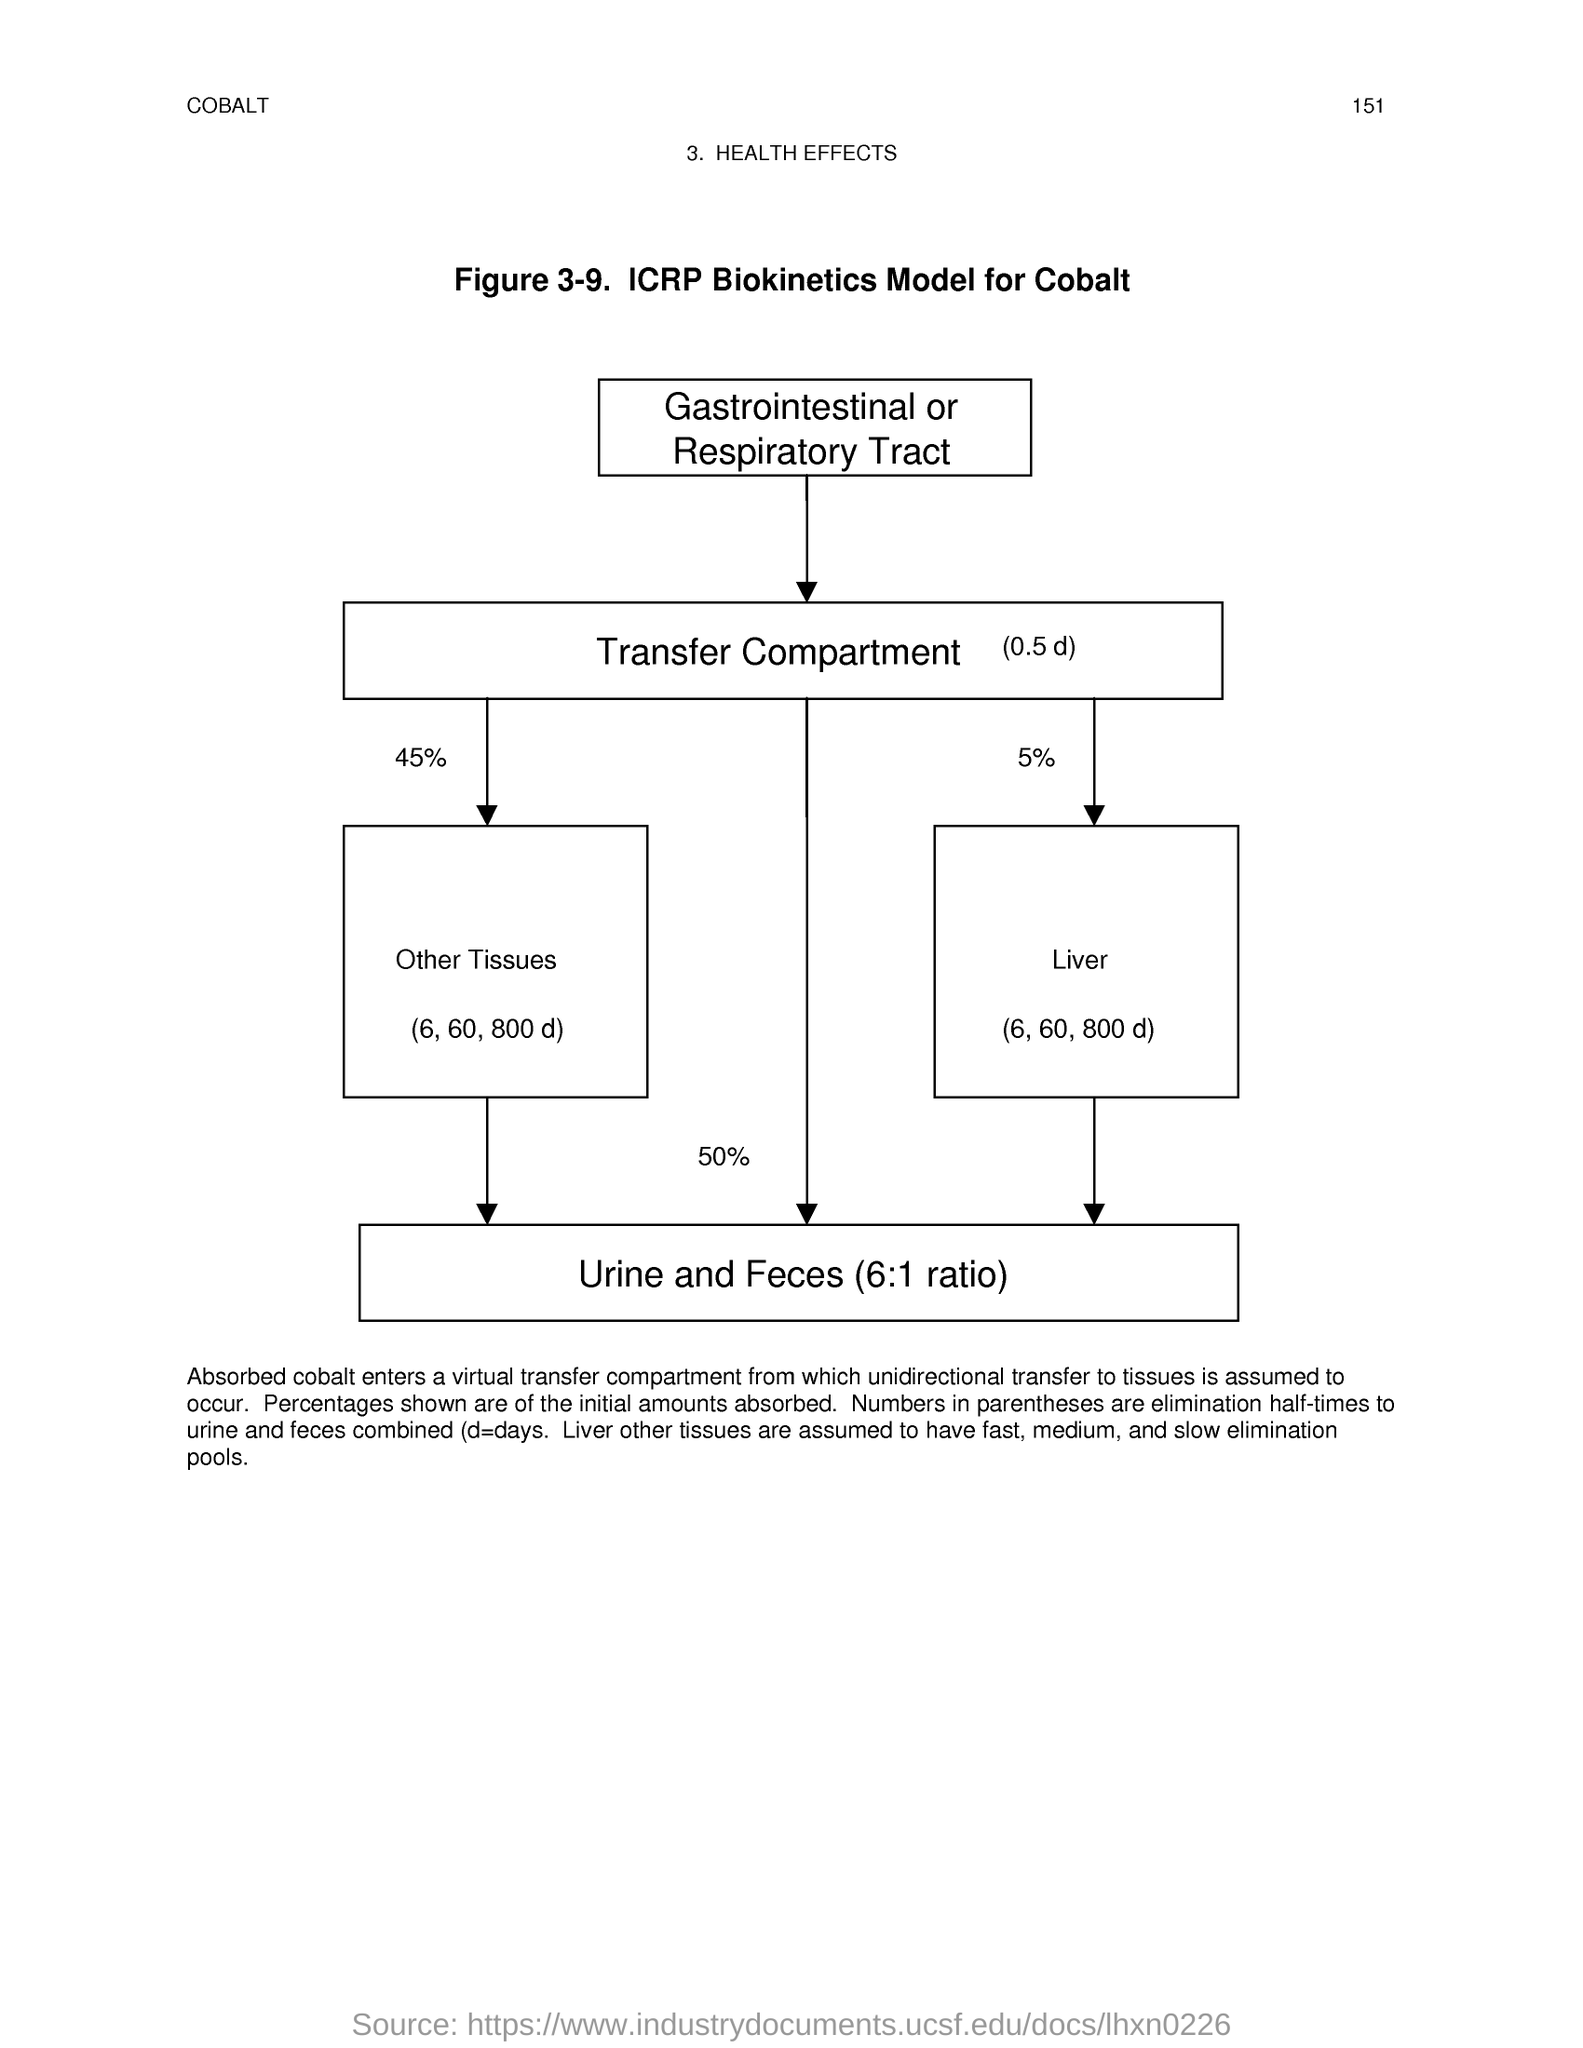Identify some key points in this picture. The ratio of urine to feces is typically 6:1. The page number is 151. 